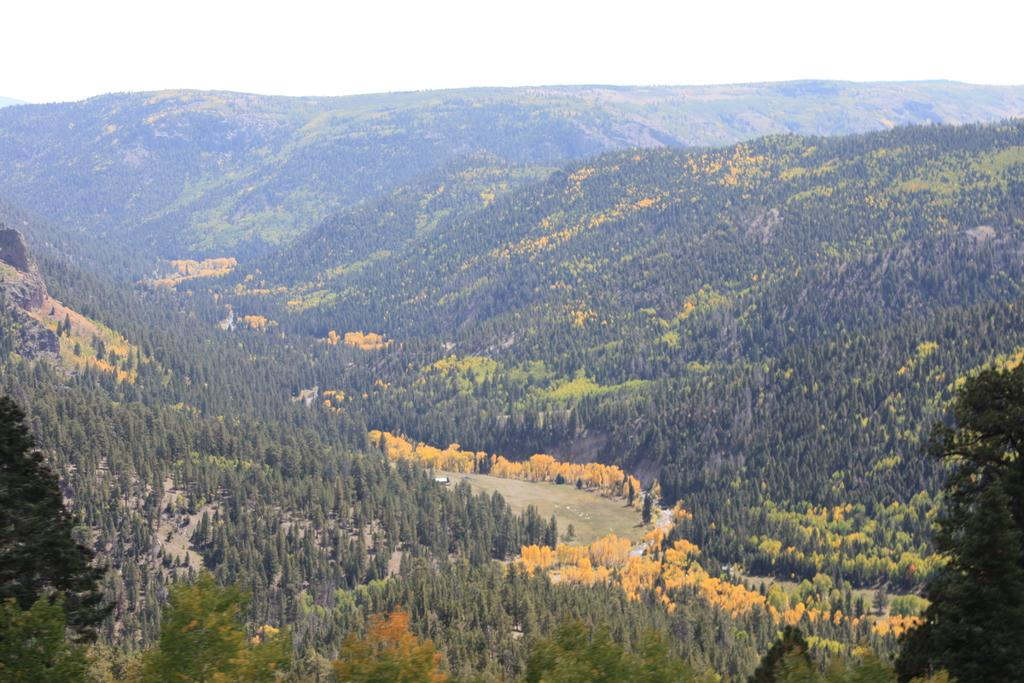What type of vegetation is present in the image? There are trees in the image. What type of geographical feature can be seen in the image? There are hills in the image. What is located in the center of the image? There is a road in the center of the image. What is visible at the top of the image? The sky is visible at the top of the image. How much ink is required to draw the trees in the image? The image is a photograph and not a drawing, so the concept of ink does not apply. How many homes are visible in the image? There is no mention of homes in the image; it features trees, hills, a road, and the sky. 